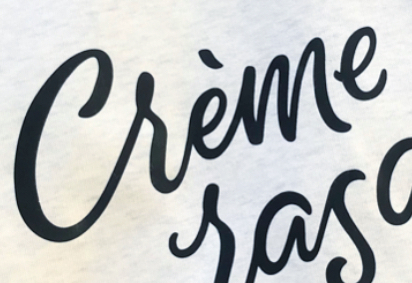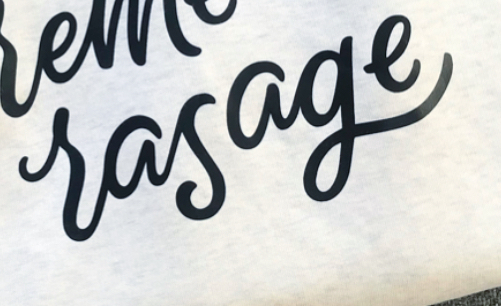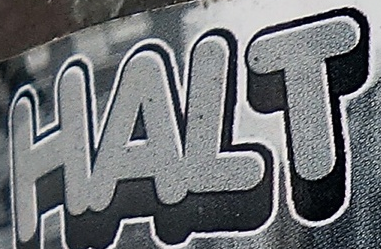What words can you see in these images in sequence, separated by a semicolon? Crème; rasage; HALT 